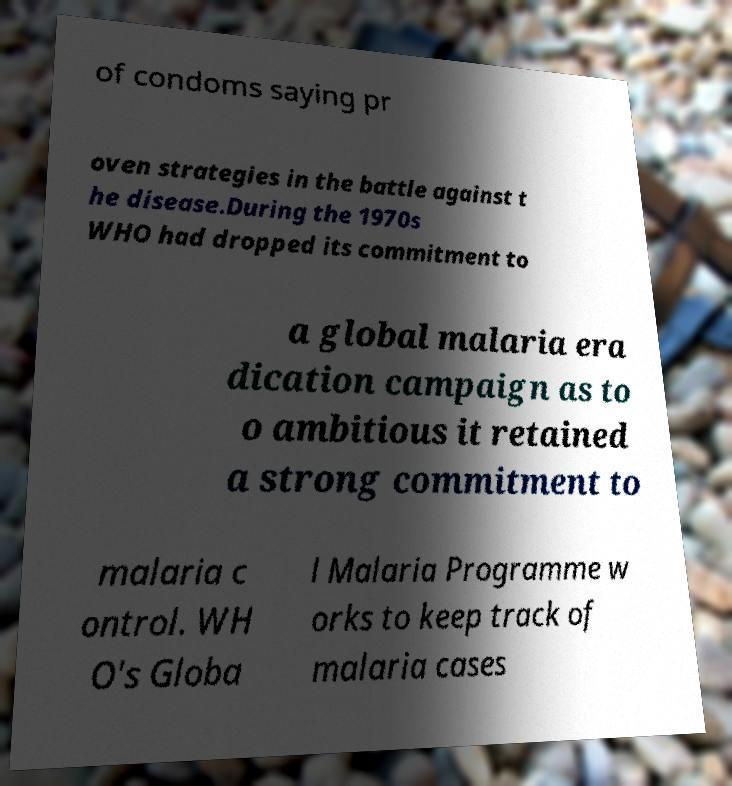Please identify and transcribe the text found in this image. of condoms saying pr oven strategies in the battle against t he disease.During the 1970s WHO had dropped its commitment to a global malaria era dication campaign as to o ambitious it retained a strong commitment to malaria c ontrol. WH O's Globa l Malaria Programme w orks to keep track of malaria cases 